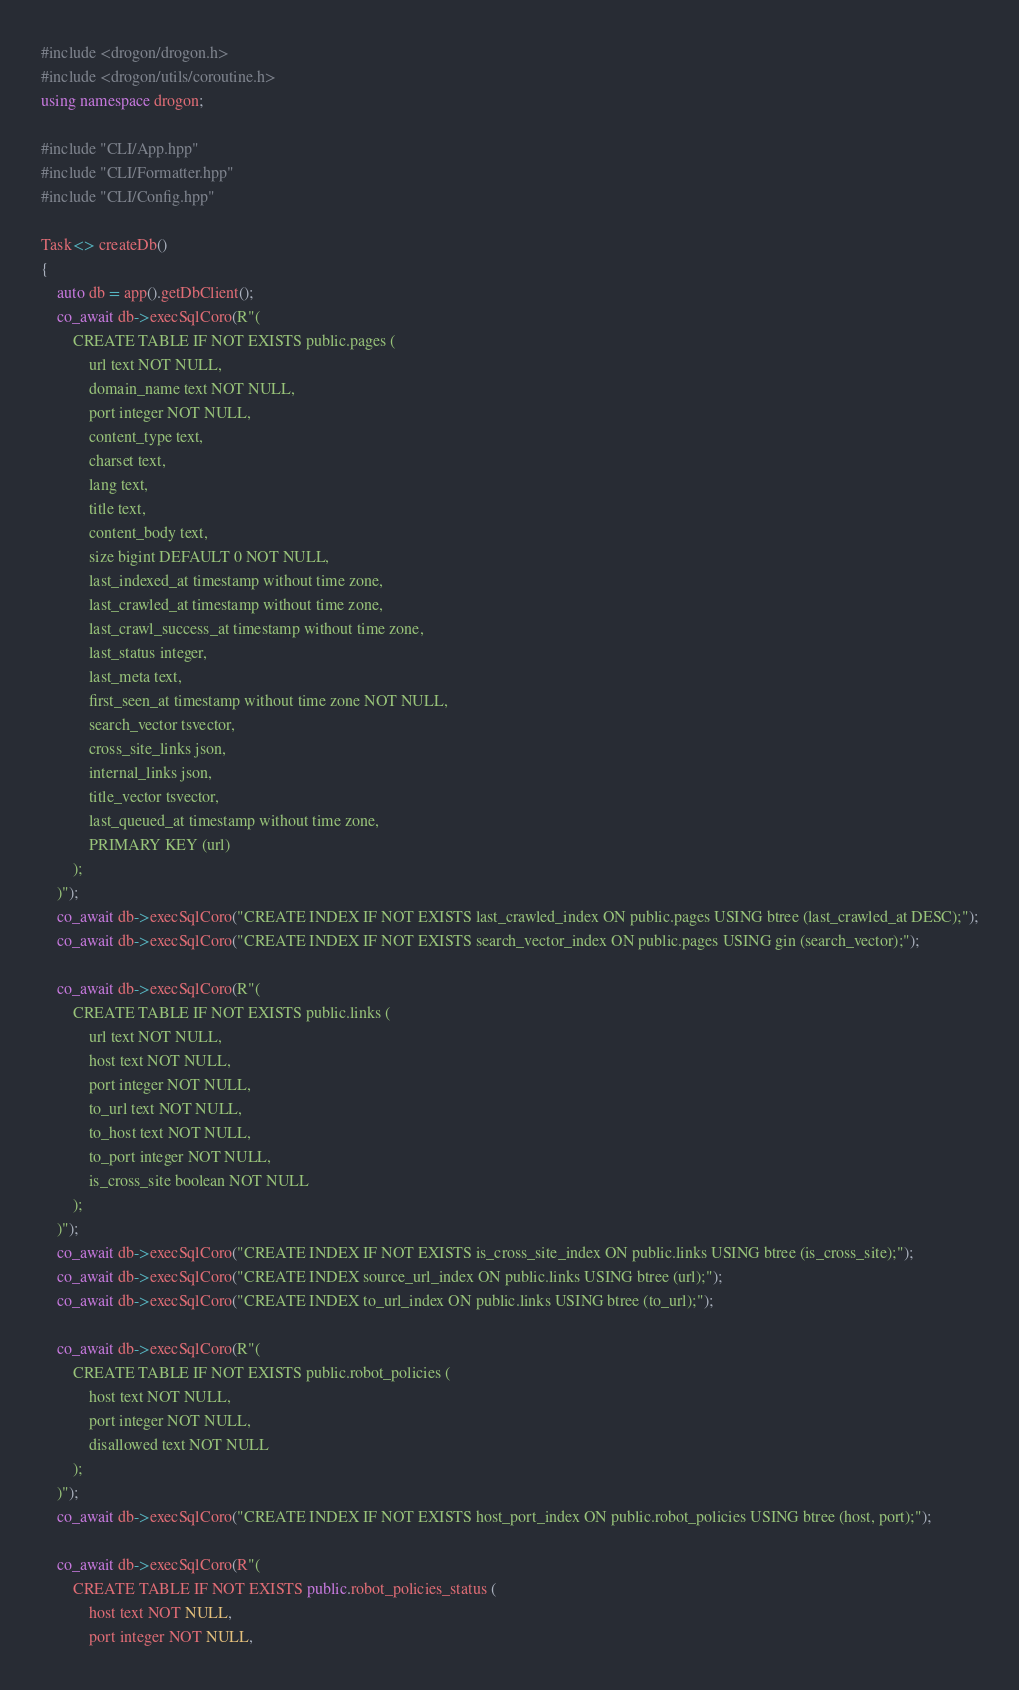<code> <loc_0><loc_0><loc_500><loc_500><_C++_>#include <drogon/drogon.h>
#include <drogon/utils/coroutine.h>
using namespace drogon;

#include "CLI/App.hpp"
#include "CLI/Formatter.hpp"
#include "CLI/Config.hpp"

Task<> createDb()
{
	auto db = app().getDbClient();
	co_await db->execSqlCoro(R"(
		CREATE TABLE IF NOT EXISTS public.pages (
			url text NOT NULL,
			domain_name text NOT NULL,
			port integer NOT NULL,
			content_type text,
			charset text,
			lang text,
			title text,
			content_body text,
			size bigint DEFAULT 0 NOT NULL,
			last_indexed_at timestamp without time zone,
			last_crawled_at timestamp without time zone,
			last_crawl_success_at timestamp without time zone,
			last_status integer,
			last_meta text,
			first_seen_at timestamp without time zone NOT NULL,
			search_vector tsvector,
			cross_site_links json,
			internal_links json,
			title_vector tsvector,
			last_queued_at timestamp without time zone,
			PRIMARY KEY (url)
		);
	)");
	co_await db->execSqlCoro("CREATE INDEX IF NOT EXISTS last_crawled_index ON public.pages USING btree (last_crawled_at DESC);");
	co_await db->execSqlCoro("CREATE INDEX IF NOT EXISTS search_vector_index ON public.pages USING gin (search_vector);");

	co_await db->execSqlCoro(R"(
		CREATE TABLE IF NOT EXISTS public.links (
			url text NOT NULL,
			host text NOT NULL,
			port integer NOT NULL,
			to_url text NOT NULL,
			to_host text NOT NULL,
			to_port integer NOT NULL,
			is_cross_site boolean NOT NULL
		);
	)");
	co_await db->execSqlCoro("CREATE INDEX IF NOT EXISTS is_cross_site_index ON public.links USING btree (is_cross_site);");
	co_await db->execSqlCoro("CREATE INDEX source_url_index ON public.links USING btree (url);");
	co_await db->execSqlCoro("CREATE INDEX to_url_index ON public.links USING btree (to_url);");

	co_await db->execSqlCoro(R"(
		CREATE TABLE IF NOT EXISTS public.robot_policies (
			host text NOT NULL,
			port integer NOT NULL,
			disallowed text NOT NULL
		);
	)");
	co_await db->execSqlCoro("CREATE INDEX IF NOT EXISTS host_port_index ON public.robot_policies USING btree (host, port);");

	co_await db->execSqlCoro(R"(
		CREATE TABLE IF NOT EXISTS public.robot_policies_status (
			host text NOT NULL,
			port integer NOT NULL,</code> 